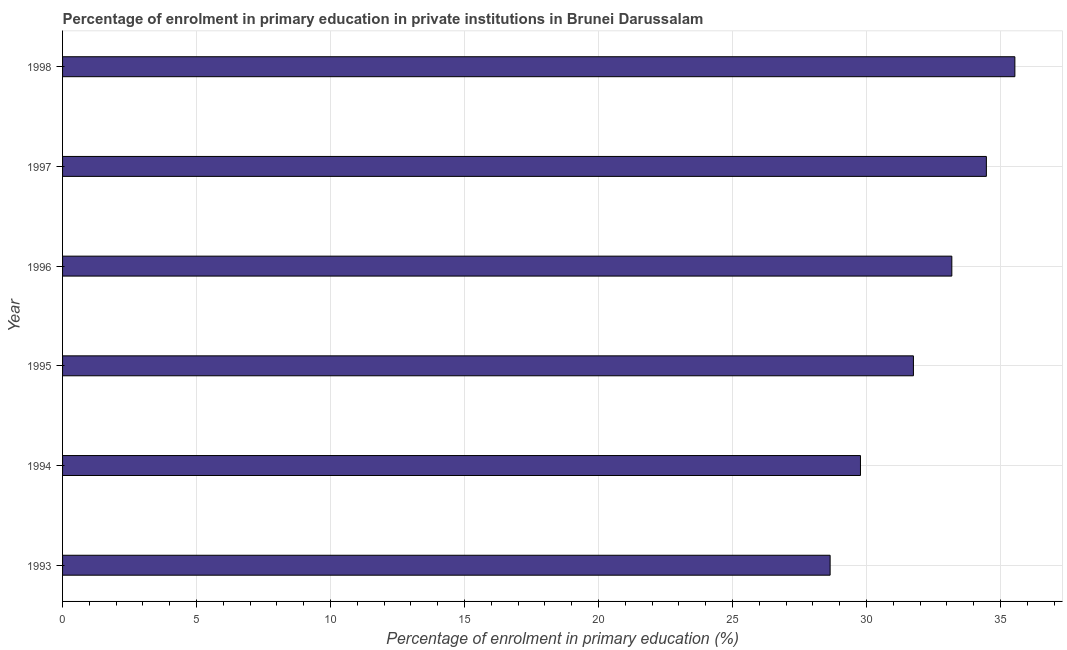Does the graph contain any zero values?
Provide a short and direct response. No. Does the graph contain grids?
Your answer should be compact. Yes. What is the title of the graph?
Your answer should be compact. Percentage of enrolment in primary education in private institutions in Brunei Darussalam. What is the label or title of the X-axis?
Provide a short and direct response. Percentage of enrolment in primary education (%). What is the label or title of the Y-axis?
Ensure brevity in your answer.  Year. What is the enrolment percentage in primary education in 1994?
Ensure brevity in your answer.  29.78. Across all years, what is the maximum enrolment percentage in primary education?
Keep it short and to the point. 35.54. Across all years, what is the minimum enrolment percentage in primary education?
Your answer should be compact. 28.64. In which year was the enrolment percentage in primary education minimum?
Provide a succinct answer. 1993. What is the sum of the enrolment percentage in primary education?
Provide a succinct answer. 193.37. What is the difference between the enrolment percentage in primary education in 1997 and 1998?
Give a very brief answer. -1.06. What is the average enrolment percentage in primary education per year?
Your answer should be compact. 32.23. What is the median enrolment percentage in primary education?
Keep it short and to the point. 32.47. Do a majority of the years between 1998 and 1996 (inclusive) have enrolment percentage in primary education greater than 34 %?
Keep it short and to the point. Yes. What is the ratio of the enrolment percentage in primary education in 1994 to that in 1996?
Your answer should be very brief. 0.9. Is the enrolment percentage in primary education in 1993 less than that in 1994?
Provide a succinct answer. Yes. Is the difference between the enrolment percentage in primary education in 1993 and 1997 greater than the difference between any two years?
Keep it short and to the point. No. What is the difference between the highest and the second highest enrolment percentage in primary education?
Keep it short and to the point. 1.06. What is the difference between the highest and the lowest enrolment percentage in primary education?
Keep it short and to the point. 6.89. In how many years, is the enrolment percentage in primary education greater than the average enrolment percentage in primary education taken over all years?
Provide a succinct answer. 3. How many bars are there?
Make the answer very short. 6. What is the difference between two consecutive major ticks on the X-axis?
Your answer should be very brief. 5. Are the values on the major ticks of X-axis written in scientific E-notation?
Your answer should be compact. No. What is the Percentage of enrolment in primary education (%) of 1993?
Provide a short and direct response. 28.64. What is the Percentage of enrolment in primary education (%) of 1994?
Your answer should be compact. 29.78. What is the Percentage of enrolment in primary education (%) in 1995?
Your answer should be compact. 31.75. What is the Percentage of enrolment in primary education (%) in 1996?
Ensure brevity in your answer.  33.18. What is the Percentage of enrolment in primary education (%) of 1997?
Provide a succinct answer. 34.47. What is the Percentage of enrolment in primary education (%) in 1998?
Your response must be concise. 35.54. What is the difference between the Percentage of enrolment in primary education (%) in 1993 and 1994?
Your answer should be very brief. -1.13. What is the difference between the Percentage of enrolment in primary education (%) in 1993 and 1995?
Provide a succinct answer. -3.11. What is the difference between the Percentage of enrolment in primary education (%) in 1993 and 1996?
Ensure brevity in your answer.  -4.54. What is the difference between the Percentage of enrolment in primary education (%) in 1993 and 1997?
Provide a succinct answer. -5.83. What is the difference between the Percentage of enrolment in primary education (%) in 1993 and 1998?
Ensure brevity in your answer.  -6.89. What is the difference between the Percentage of enrolment in primary education (%) in 1994 and 1995?
Keep it short and to the point. -1.98. What is the difference between the Percentage of enrolment in primary education (%) in 1994 and 1996?
Offer a very short reply. -3.41. What is the difference between the Percentage of enrolment in primary education (%) in 1994 and 1997?
Give a very brief answer. -4.7. What is the difference between the Percentage of enrolment in primary education (%) in 1994 and 1998?
Provide a succinct answer. -5.76. What is the difference between the Percentage of enrolment in primary education (%) in 1995 and 1996?
Offer a terse response. -1.43. What is the difference between the Percentage of enrolment in primary education (%) in 1995 and 1997?
Your answer should be compact. -2.72. What is the difference between the Percentage of enrolment in primary education (%) in 1995 and 1998?
Provide a short and direct response. -3.79. What is the difference between the Percentage of enrolment in primary education (%) in 1996 and 1997?
Offer a terse response. -1.29. What is the difference between the Percentage of enrolment in primary education (%) in 1996 and 1998?
Keep it short and to the point. -2.35. What is the difference between the Percentage of enrolment in primary education (%) in 1997 and 1998?
Provide a succinct answer. -1.06. What is the ratio of the Percentage of enrolment in primary education (%) in 1993 to that in 1994?
Keep it short and to the point. 0.96. What is the ratio of the Percentage of enrolment in primary education (%) in 1993 to that in 1995?
Your response must be concise. 0.9. What is the ratio of the Percentage of enrolment in primary education (%) in 1993 to that in 1996?
Make the answer very short. 0.86. What is the ratio of the Percentage of enrolment in primary education (%) in 1993 to that in 1997?
Your answer should be very brief. 0.83. What is the ratio of the Percentage of enrolment in primary education (%) in 1993 to that in 1998?
Ensure brevity in your answer.  0.81. What is the ratio of the Percentage of enrolment in primary education (%) in 1994 to that in 1995?
Provide a succinct answer. 0.94. What is the ratio of the Percentage of enrolment in primary education (%) in 1994 to that in 1996?
Provide a succinct answer. 0.9. What is the ratio of the Percentage of enrolment in primary education (%) in 1994 to that in 1997?
Provide a short and direct response. 0.86. What is the ratio of the Percentage of enrolment in primary education (%) in 1994 to that in 1998?
Offer a terse response. 0.84. What is the ratio of the Percentage of enrolment in primary education (%) in 1995 to that in 1996?
Offer a terse response. 0.96. What is the ratio of the Percentage of enrolment in primary education (%) in 1995 to that in 1997?
Your response must be concise. 0.92. What is the ratio of the Percentage of enrolment in primary education (%) in 1995 to that in 1998?
Ensure brevity in your answer.  0.89. What is the ratio of the Percentage of enrolment in primary education (%) in 1996 to that in 1997?
Your answer should be compact. 0.96. What is the ratio of the Percentage of enrolment in primary education (%) in 1996 to that in 1998?
Offer a terse response. 0.93. What is the ratio of the Percentage of enrolment in primary education (%) in 1997 to that in 1998?
Make the answer very short. 0.97. 